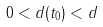<formula> <loc_0><loc_0><loc_500><loc_500>0 < d ( t _ { 0 } ) < d</formula> 